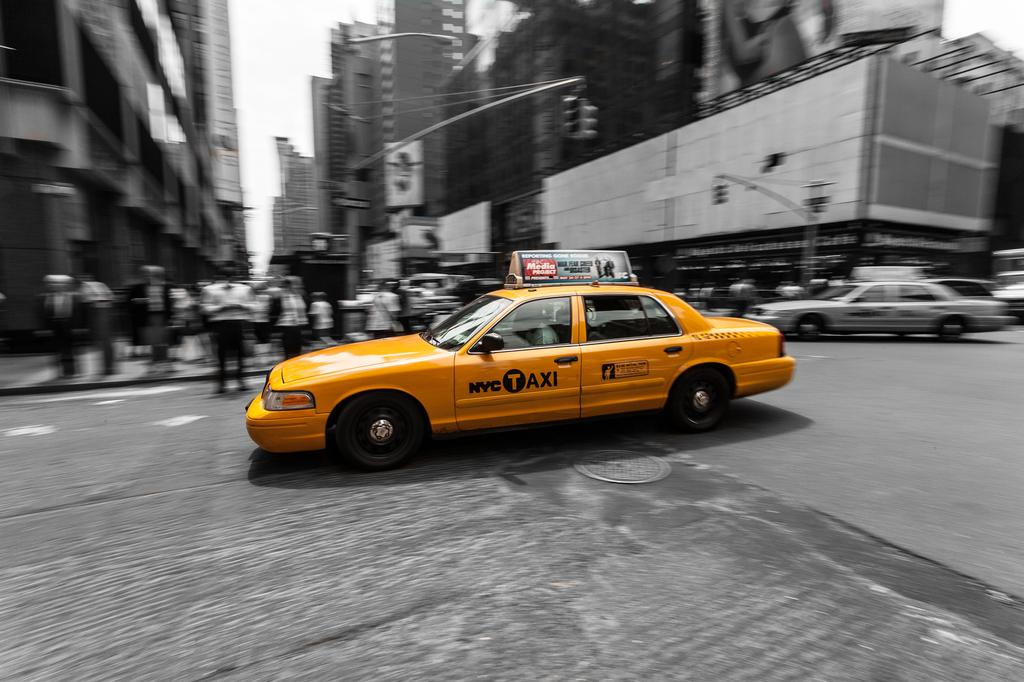<image>
Give a short and clear explanation of the subsequent image. A yellow cab says NYC Taxi on the driver's door. 